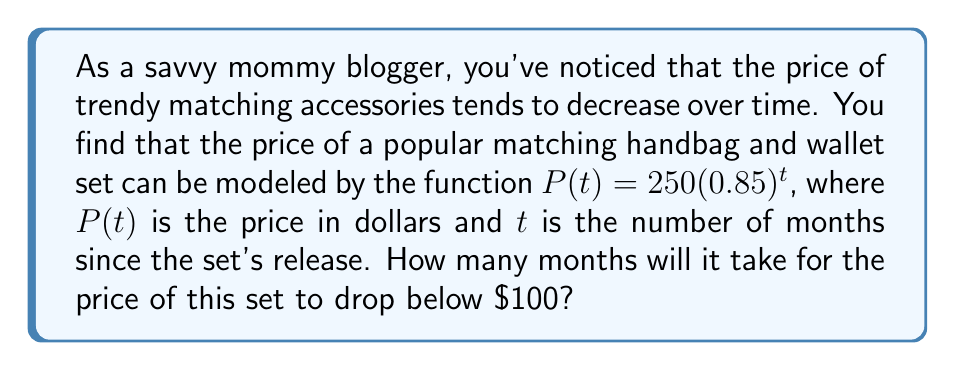Can you answer this question? Let's approach this step-by-step:

1) We need to find when $P(t) < 100$. So, we set up the inequality:

   $250(0.85)^t < 100$

2) Divide both sides by 250:

   $(0.85)^t < \frac{100}{250} = 0.4$

3) Now, we need to solve for $t$. We can do this by taking the logarithm of both sides. Let's use the natural log:

   $\ln(0.85)^t < \ln(0.4)$

4) Using the logarithm property $\ln(a^b) = b\ln(a)$:

   $t\ln(0.85) < \ln(0.4)$

5) Divide both sides by $\ln(0.85)$ (note that this flips the inequality sign because $\ln(0.85)$ is negative):

   $t > \frac{\ln(0.4)}{\ln(0.85)}$

6) Using a calculator:

   $t > \frac{\ln(0.4)}{\ln(0.85)} \approx 5.90$

7) Since $t$ represents months and must be a whole number, we round up to the next integer.
Answer: 6 months 